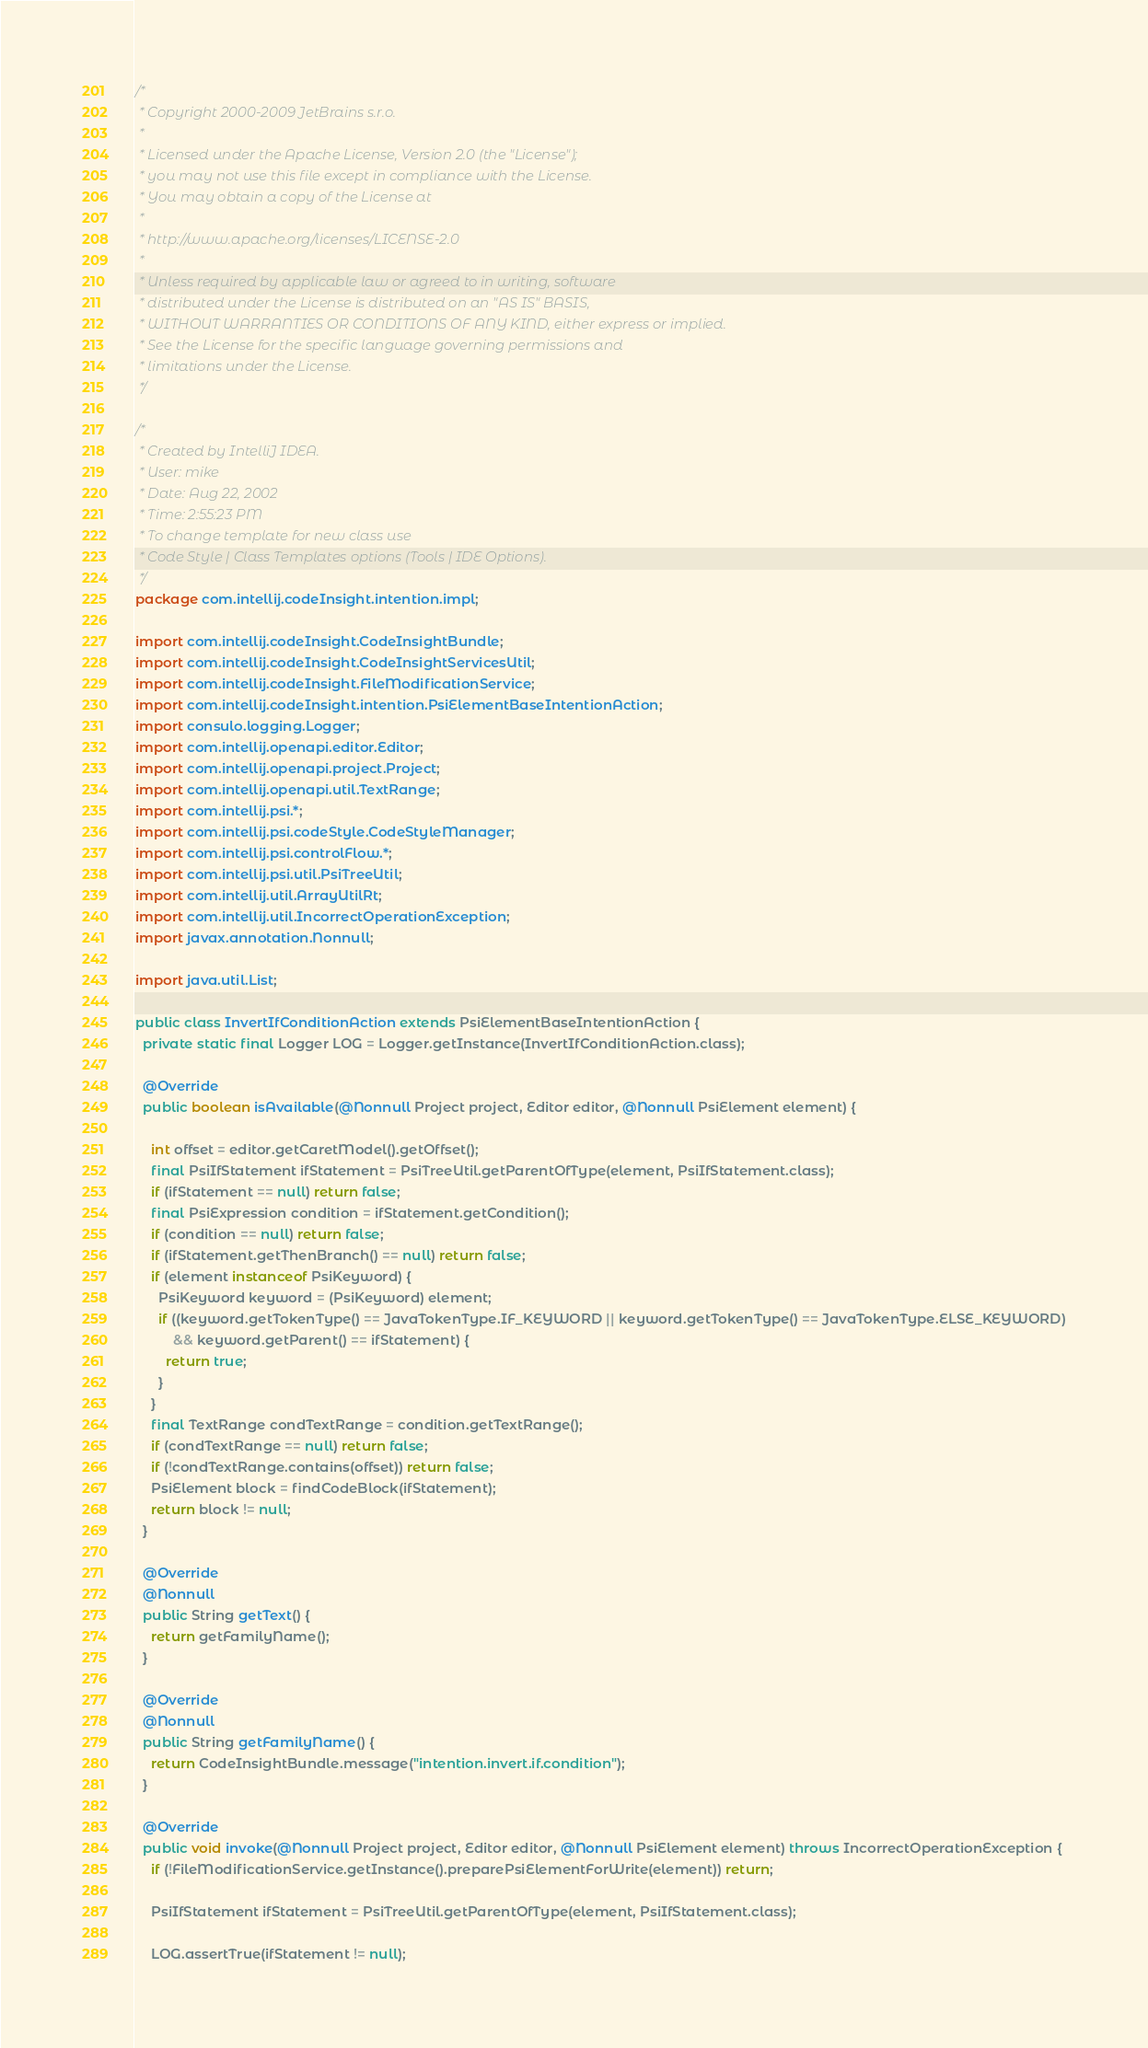Convert code to text. <code><loc_0><loc_0><loc_500><loc_500><_Java_>/*
 * Copyright 2000-2009 JetBrains s.r.o.
 *
 * Licensed under the Apache License, Version 2.0 (the "License");
 * you may not use this file except in compliance with the License.
 * You may obtain a copy of the License at
 *
 * http://www.apache.org/licenses/LICENSE-2.0
 *
 * Unless required by applicable law or agreed to in writing, software
 * distributed under the License is distributed on an "AS IS" BASIS,
 * WITHOUT WARRANTIES OR CONDITIONS OF ANY KIND, either express or implied.
 * See the License for the specific language governing permissions and
 * limitations under the License.
 */

/*
 * Created by IntelliJ IDEA.
 * User: mike
 * Date: Aug 22, 2002
 * Time: 2:55:23 PM
 * To change template for new class use
 * Code Style | Class Templates options (Tools | IDE Options).
 */
package com.intellij.codeInsight.intention.impl;

import com.intellij.codeInsight.CodeInsightBundle;
import com.intellij.codeInsight.CodeInsightServicesUtil;
import com.intellij.codeInsight.FileModificationService;
import com.intellij.codeInsight.intention.PsiElementBaseIntentionAction;
import consulo.logging.Logger;
import com.intellij.openapi.editor.Editor;
import com.intellij.openapi.project.Project;
import com.intellij.openapi.util.TextRange;
import com.intellij.psi.*;
import com.intellij.psi.codeStyle.CodeStyleManager;
import com.intellij.psi.controlFlow.*;
import com.intellij.psi.util.PsiTreeUtil;
import com.intellij.util.ArrayUtilRt;
import com.intellij.util.IncorrectOperationException;
import javax.annotation.Nonnull;

import java.util.List;

public class InvertIfConditionAction extends PsiElementBaseIntentionAction {
  private static final Logger LOG = Logger.getInstance(InvertIfConditionAction.class);

  @Override
  public boolean isAvailable(@Nonnull Project project, Editor editor, @Nonnull PsiElement element) {

    int offset = editor.getCaretModel().getOffset();
    final PsiIfStatement ifStatement = PsiTreeUtil.getParentOfType(element, PsiIfStatement.class);
    if (ifStatement == null) return false;
    final PsiExpression condition = ifStatement.getCondition();
    if (condition == null) return false;
    if (ifStatement.getThenBranch() == null) return false;
    if (element instanceof PsiKeyword) {
      PsiKeyword keyword = (PsiKeyword) element;
      if ((keyword.getTokenType() == JavaTokenType.IF_KEYWORD || keyword.getTokenType() == JavaTokenType.ELSE_KEYWORD)
          && keyword.getParent() == ifStatement) {
        return true;
      }
    }
    final TextRange condTextRange = condition.getTextRange();
    if (condTextRange == null) return false;
    if (!condTextRange.contains(offset)) return false;
    PsiElement block = findCodeBlock(ifStatement);
    return block != null;
  }

  @Override
  @Nonnull
  public String getText() {
    return getFamilyName();
  }

  @Override
  @Nonnull
  public String getFamilyName() {
    return CodeInsightBundle.message("intention.invert.if.condition");
  }

  @Override
  public void invoke(@Nonnull Project project, Editor editor, @Nonnull PsiElement element) throws IncorrectOperationException {
    if (!FileModificationService.getInstance().preparePsiElementForWrite(element)) return;

    PsiIfStatement ifStatement = PsiTreeUtil.getParentOfType(element, PsiIfStatement.class);

    LOG.assertTrue(ifStatement != null);</code> 